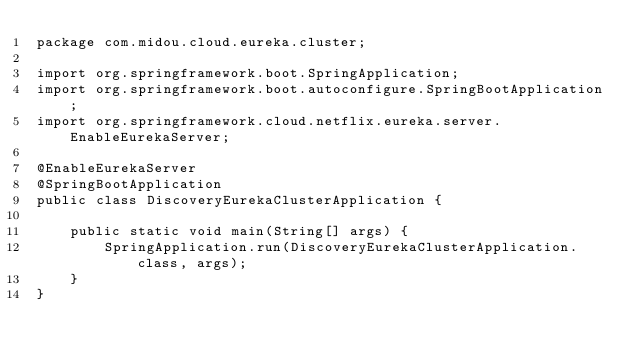Convert code to text. <code><loc_0><loc_0><loc_500><loc_500><_Java_>package com.midou.cloud.eureka.cluster;

import org.springframework.boot.SpringApplication;
import org.springframework.boot.autoconfigure.SpringBootApplication;
import org.springframework.cloud.netflix.eureka.server.EnableEurekaServer;

@EnableEurekaServer
@SpringBootApplication
public class DiscoveryEurekaClusterApplication {

    public static void main(String[] args) {
        SpringApplication.run(DiscoveryEurekaClusterApplication.class, args);
    }
}
</code> 